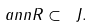Convert formula to latex. <formula><loc_0><loc_0><loc_500><loc_500>\ a n n R \subset \ J .</formula> 